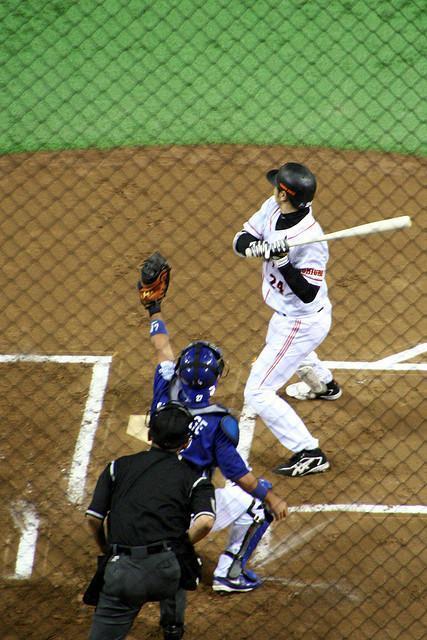How many people are there?
Give a very brief answer. 3. How many elephant butts can be seen?
Give a very brief answer. 0. 